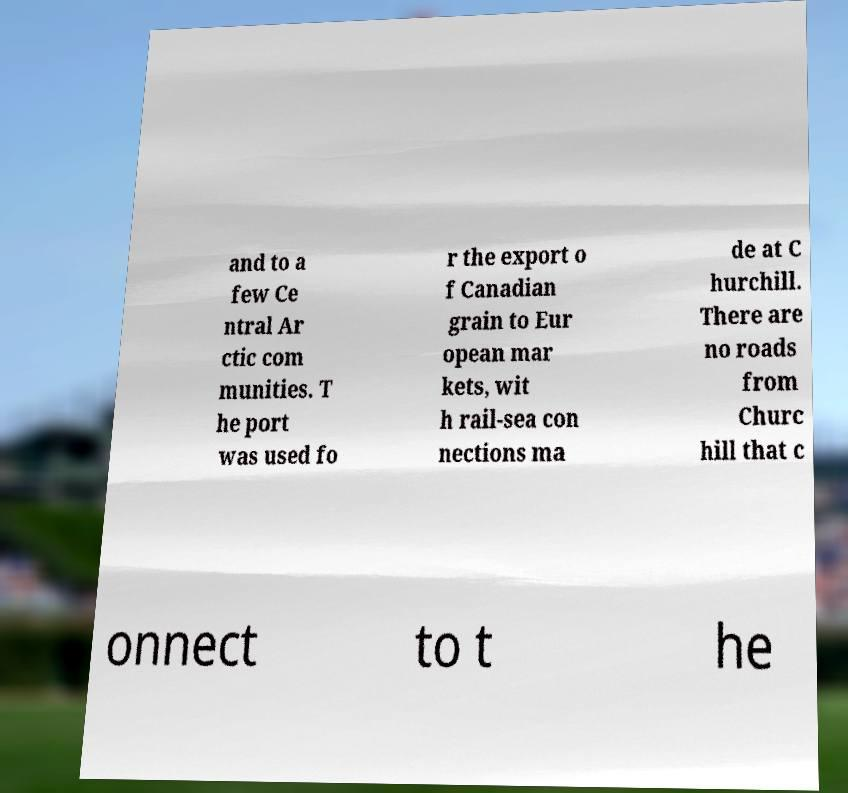Please read and relay the text visible in this image. What does it say? and to a few Ce ntral Ar ctic com munities. T he port was used fo r the export o f Canadian grain to Eur opean mar kets, wit h rail-sea con nections ma de at C hurchill. There are no roads from Churc hill that c onnect to t he 